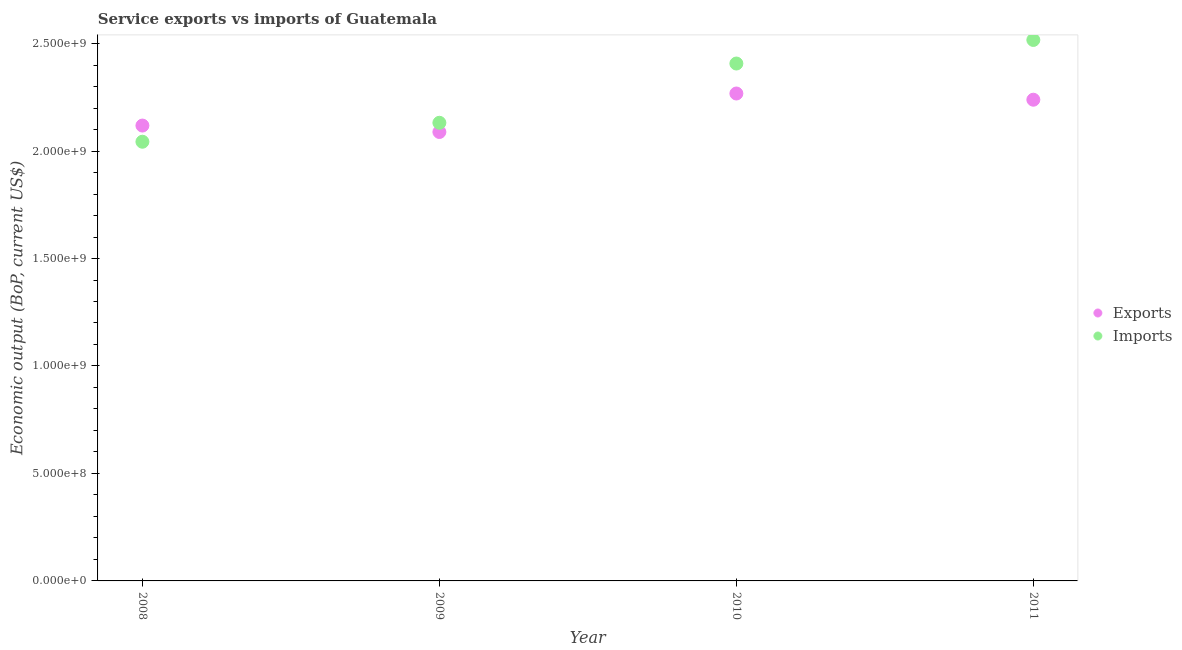Is the number of dotlines equal to the number of legend labels?
Your answer should be compact. Yes. What is the amount of service imports in 2011?
Provide a succinct answer. 2.52e+09. Across all years, what is the maximum amount of service exports?
Offer a very short reply. 2.27e+09. Across all years, what is the minimum amount of service imports?
Give a very brief answer. 2.04e+09. In which year was the amount of service imports maximum?
Provide a short and direct response. 2011. What is the total amount of service exports in the graph?
Provide a short and direct response. 8.71e+09. What is the difference between the amount of service imports in 2009 and that in 2010?
Offer a terse response. -2.76e+08. What is the difference between the amount of service exports in 2010 and the amount of service imports in 2008?
Ensure brevity in your answer.  2.24e+08. What is the average amount of service exports per year?
Provide a short and direct response. 2.18e+09. In the year 2008, what is the difference between the amount of service imports and amount of service exports?
Offer a terse response. -7.53e+07. What is the ratio of the amount of service imports in 2009 to that in 2011?
Your answer should be very brief. 0.85. What is the difference between the highest and the second highest amount of service exports?
Offer a very short reply. 2.89e+07. What is the difference between the highest and the lowest amount of service exports?
Keep it short and to the point. 1.79e+08. Is the sum of the amount of service imports in 2008 and 2009 greater than the maximum amount of service exports across all years?
Your answer should be very brief. Yes. Does the amount of service imports monotonically increase over the years?
Keep it short and to the point. Yes. Is the amount of service exports strictly greater than the amount of service imports over the years?
Give a very brief answer. No. Is the amount of service exports strictly less than the amount of service imports over the years?
Offer a very short reply. No. Does the graph contain any zero values?
Your response must be concise. No. Does the graph contain grids?
Give a very brief answer. No. How many legend labels are there?
Make the answer very short. 2. What is the title of the graph?
Give a very brief answer. Service exports vs imports of Guatemala. Does "Primary school" appear as one of the legend labels in the graph?
Ensure brevity in your answer.  No. What is the label or title of the X-axis?
Your response must be concise. Year. What is the label or title of the Y-axis?
Ensure brevity in your answer.  Economic output (BoP, current US$). What is the Economic output (BoP, current US$) in Exports in 2008?
Keep it short and to the point. 2.12e+09. What is the Economic output (BoP, current US$) in Imports in 2008?
Offer a very short reply. 2.04e+09. What is the Economic output (BoP, current US$) of Exports in 2009?
Keep it short and to the point. 2.09e+09. What is the Economic output (BoP, current US$) in Imports in 2009?
Offer a very short reply. 2.13e+09. What is the Economic output (BoP, current US$) in Exports in 2010?
Offer a very short reply. 2.27e+09. What is the Economic output (BoP, current US$) in Imports in 2010?
Offer a terse response. 2.41e+09. What is the Economic output (BoP, current US$) of Exports in 2011?
Your answer should be compact. 2.24e+09. What is the Economic output (BoP, current US$) of Imports in 2011?
Your answer should be very brief. 2.52e+09. Across all years, what is the maximum Economic output (BoP, current US$) in Exports?
Give a very brief answer. 2.27e+09. Across all years, what is the maximum Economic output (BoP, current US$) of Imports?
Offer a terse response. 2.52e+09. Across all years, what is the minimum Economic output (BoP, current US$) in Exports?
Your answer should be very brief. 2.09e+09. Across all years, what is the minimum Economic output (BoP, current US$) in Imports?
Make the answer very short. 2.04e+09. What is the total Economic output (BoP, current US$) in Exports in the graph?
Your answer should be compact. 8.71e+09. What is the total Economic output (BoP, current US$) of Imports in the graph?
Make the answer very short. 9.10e+09. What is the difference between the Economic output (BoP, current US$) of Exports in 2008 and that in 2009?
Keep it short and to the point. 2.99e+07. What is the difference between the Economic output (BoP, current US$) in Imports in 2008 and that in 2009?
Offer a terse response. -8.82e+07. What is the difference between the Economic output (BoP, current US$) in Exports in 2008 and that in 2010?
Keep it short and to the point. -1.49e+08. What is the difference between the Economic output (BoP, current US$) in Imports in 2008 and that in 2010?
Your response must be concise. -3.64e+08. What is the difference between the Economic output (BoP, current US$) of Exports in 2008 and that in 2011?
Ensure brevity in your answer.  -1.20e+08. What is the difference between the Economic output (BoP, current US$) in Imports in 2008 and that in 2011?
Make the answer very short. -4.74e+08. What is the difference between the Economic output (BoP, current US$) in Exports in 2009 and that in 2010?
Keep it short and to the point. -1.79e+08. What is the difference between the Economic output (BoP, current US$) of Imports in 2009 and that in 2010?
Offer a very short reply. -2.76e+08. What is the difference between the Economic output (BoP, current US$) in Exports in 2009 and that in 2011?
Your answer should be compact. -1.50e+08. What is the difference between the Economic output (BoP, current US$) of Imports in 2009 and that in 2011?
Provide a short and direct response. -3.85e+08. What is the difference between the Economic output (BoP, current US$) in Exports in 2010 and that in 2011?
Your answer should be very brief. 2.89e+07. What is the difference between the Economic output (BoP, current US$) of Imports in 2010 and that in 2011?
Make the answer very short. -1.10e+08. What is the difference between the Economic output (BoP, current US$) in Exports in 2008 and the Economic output (BoP, current US$) in Imports in 2009?
Keep it short and to the point. -1.29e+07. What is the difference between the Economic output (BoP, current US$) in Exports in 2008 and the Economic output (BoP, current US$) in Imports in 2010?
Give a very brief answer. -2.89e+08. What is the difference between the Economic output (BoP, current US$) of Exports in 2008 and the Economic output (BoP, current US$) of Imports in 2011?
Your answer should be compact. -3.98e+08. What is the difference between the Economic output (BoP, current US$) in Exports in 2009 and the Economic output (BoP, current US$) in Imports in 2010?
Keep it short and to the point. -3.19e+08. What is the difference between the Economic output (BoP, current US$) in Exports in 2009 and the Economic output (BoP, current US$) in Imports in 2011?
Your answer should be compact. -4.28e+08. What is the difference between the Economic output (BoP, current US$) in Exports in 2010 and the Economic output (BoP, current US$) in Imports in 2011?
Offer a very short reply. -2.49e+08. What is the average Economic output (BoP, current US$) of Exports per year?
Offer a very short reply. 2.18e+09. What is the average Economic output (BoP, current US$) in Imports per year?
Your response must be concise. 2.27e+09. In the year 2008, what is the difference between the Economic output (BoP, current US$) in Exports and Economic output (BoP, current US$) in Imports?
Give a very brief answer. 7.53e+07. In the year 2009, what is the difference between the Economic output (BoP, current US$) of Exports and Economic output (BoP, current US$) of Imports?
Give a very brief answer. -4.28e+07. In the year 2010, what is the difference between the Economic output (BoP, current US$) of Exports and Economic output (BoP, current US$) of Imports?
Your answer should be compact. -1.39e+08. In the year 2011, what is the difference between the Economic output (BoP, current US$) of Exports and Economic output (BoP, current US$) of Imports?
Offer a very short reply. -2.78e+08. What is the ratio of the Economic output (BoP, current US$) in Exports in 2008 to that in 2009?
Provide a short and direct response. 1.01. What is the ratio of the Economic output (BoP, current US$) of Imports in 2008 to that in 2009?
Provide a succinct answer. 0.96. What is the ratio of the Economic output (BoP, current US$) of Exports in 2008 to that in 2010?
Your answer should be compact. 0.93. What is the ratio of the Economic output (BoP, current US$) of Imports in 2008 to that in 2010?
Offer a terse response. 0.85. What is the ratio of the Economic output (BoP, current US$) of Exports in 2008 to that in 2011?
Provide a short and direct response. 0.95. What is the ratio of the Economic output (BoP, current US$) in Imports in 2008 to that in 2011?
Your answer should be very brief. 0.81. What is the ratio of the Economic output (BoP, current US$) in Exports in 2009 to that in 2010?
Keep it short and to the point. 0.92. What is the ratio of the Economic output (BoP, current US$) in Imports in 2009 to that in 2010?
Make the answer very short. 0.89. What is the ratio of the Economic output (BoP, current US$) of Exports in 2009 to that in 2011?
Offer a very short reply. 0.93. What is the ratio of the Economic output (BoP, current US$) in Imports in 2009 to that in 2011?
Keep it short and to the point. 0.85. What is the ratio of the Economic output (BoP, current US$) in Exports in 2010 to that in 2011?
Make the answer very short. 1.01. What is the ratio of the Economic output (BoP, current US$) in Imports in 2010 to that in 2011?
Give a very brief answer. 0.96. What is the difference between the highest and the second highest Economic output (BoP, current US$) in Exports?
Make the answer very short. 2.89e+07. What is the difference between the highest and the second highest Economic output (BoP, current US$) of Imports?
Provide a succinct answer. 1.10e+08. What is the difference between the highest and the lowest Economic output (BoP, current US$) in Exports?
Keep it short and to the point. 1.79e+08. What is the difference between the highest and the lowest Economic output (BoP, current US$) of Imports?
Ensure brevity in your answer.  4.74e+08. 